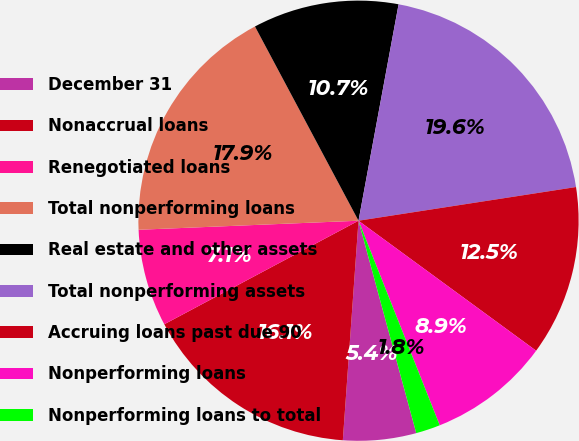<chart> <loc_0><loc_0><loc_500><loc_500><pie_chart><fcel>December 31<fcel>Nonaccrual loans<fcel>Renegotiated loans<fcel>Total nonperforming loans<fcel>Real estate and other assets<fcel>Total nonperforming assets<fcel>Accruing loans past due 90<fcel>Nonperforming loans<fcel>Nonperforming loans to total<nl><fcel>5.36%<fcel>16.07%<fcel>7.14%<fcel>17.86%<fcel>10.71%<fcel>19.64%<fcel>12.5%<fcel>8.93%<fcel>1.79%<nl></chart> 